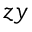Convert formula to latex. <formula><loc_0><loc_0><loc_500><loc_500>z y</formula> 